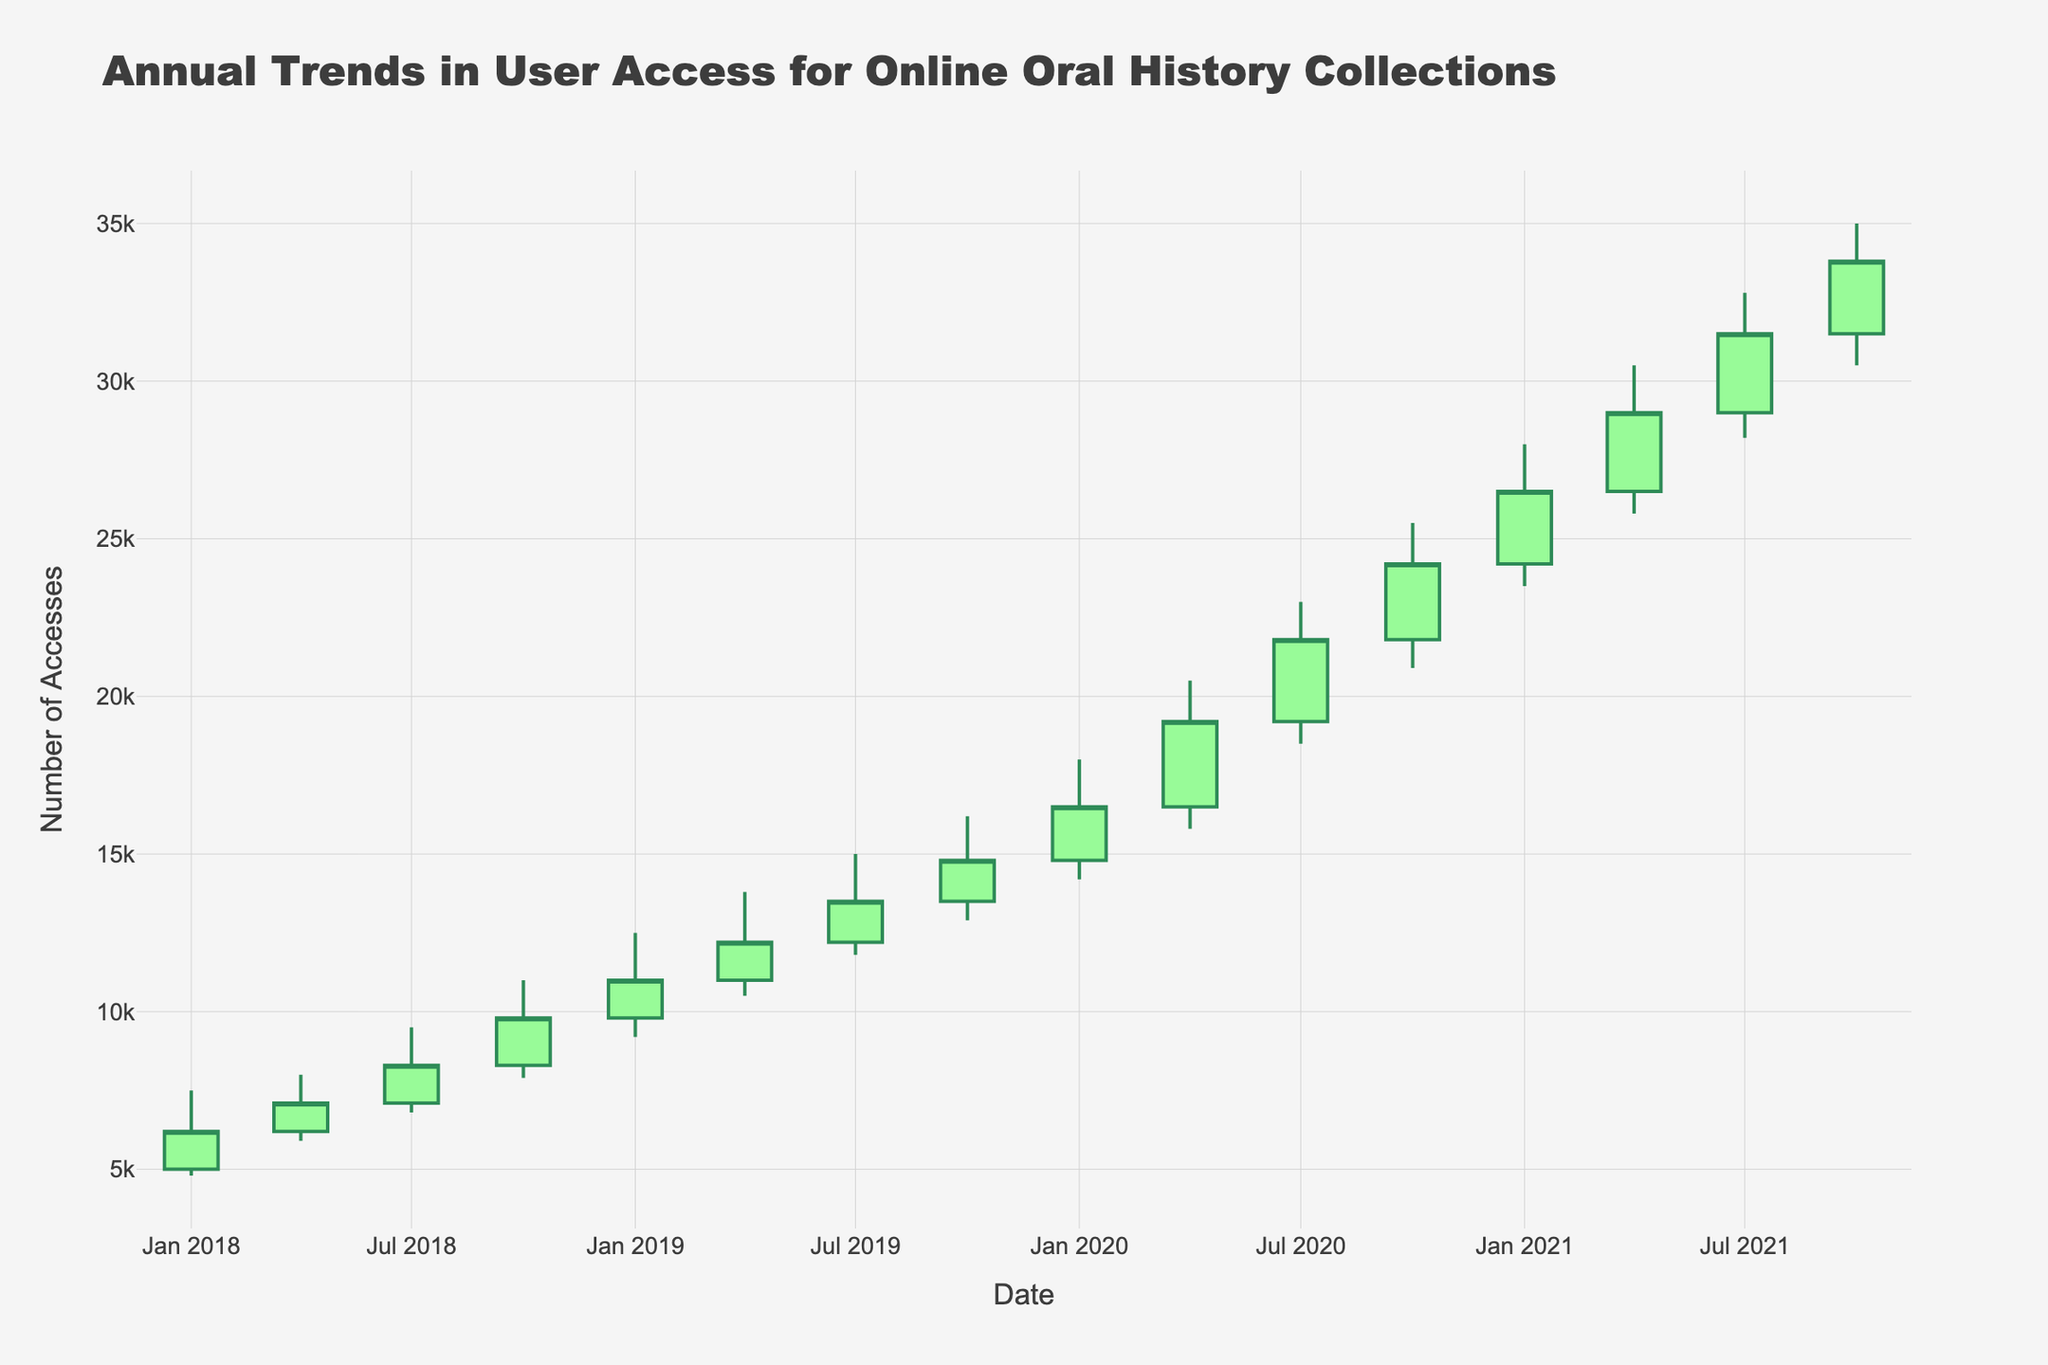What is the title of the chart? The title of the chart is displayed at the top and reads 'Annual Trends in User Access for Online Oral History Collections'.
Answer: Annual Trends in User Access for Online Oral History Collections How many data points are represented in the chart? Each point represents one quarter, and the data spans 4 years with 4 quarters each year from 2018 to 2021. Therefore, there are 4 * 4 = 16 data points.
Answer: 16 During which quarter does the chart show the highest number of accesses? The highest peak on the chart occurs in the period with the highest 'High' value. The data and visual confirm this as the fourth quarter of 2021 with a 'High' value of 35,000 accesses.
Answer: 2021 Q4 What trend in user access can be observed from 2018 to 2021? The trend shows a steady increase in user access over time. Each year's data points visibly rise higher compared to the previous year, indicating a growth trend.
Answer: Steady increase What were the number of accesses at the beginning and end of the 3-year period shown in the chart? The chart shows the 'Open' value of the first quarter of 2018 as 5000 and the 'Close' value of the last quarter of 2021 as 33,800.
Answer: 5000 and 33800 Which year had the greatest increase in user accesses during its last quarter? Each year's last quarter 'Open' and 'Close' values need to be compared. The greatest increase, calculated as 'Close' - 'Open', is in 2020 (24200 - 21800) = 2400.
Answer: 2020 When was the biggest spike in access during the given time period? The biggest spike corresponds to the highest 'High' value in the chart, which occurred in the fourth quarter of 2021, showing access up to 35,000.
Answer: 2021 Q4 What is the difference between the highest and lowest number of accesses recorded in the third quarter of 2020? In the third quarter of 2020, the 'High' is 23,000 and the 'Low' is 18,500. The difference is 23,000 - 18,500 = 4,500.
Answer: 4500 Compare the number of accesses at the end of 2019 with the beginning of 2020. Did the user access increase or decrease? The chart shows a 'Close' value of 14800 at the end of 2019 and an 'Open' value of 14800 at the beginning of 2020, remaining the same, thus no increase or decrease.
Answer: Same Was there any quarter in which user access statistics remained the same at the beginning and the end? The chart shows each 'Open' and 'Close' value. A comparison reveals that no quarter displayed the same 'Open' and 'Close' values throughout the given data.
Answer: No 